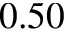<formula> <loc_0><loc_0><loc_500><loc_500>0 . 5 0</formula> 